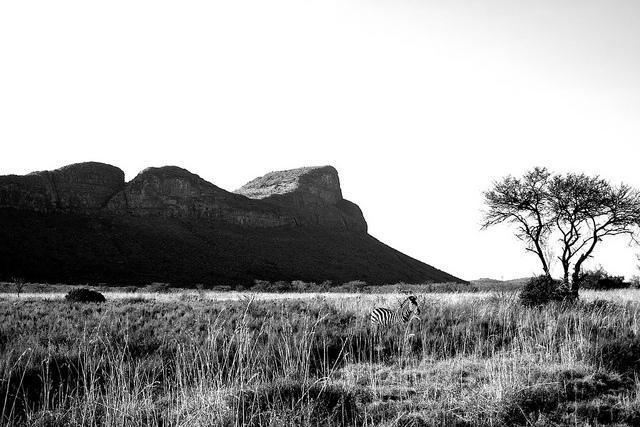How many trees can be seen?
Give a very brief answer. 1. How many people are wearing a pink shirt?
Give a very brief answer. 0. 